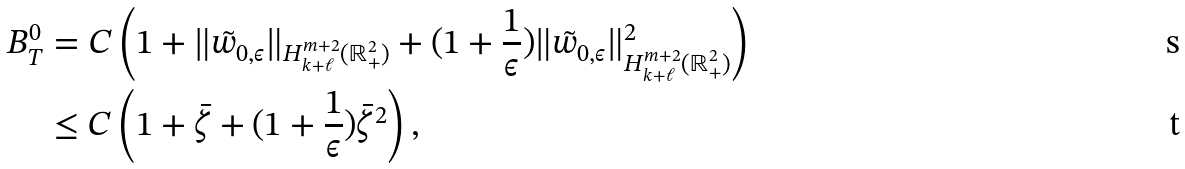Convert formula to latex. <formula><loc_0><loc_0><loc_500><loc_500>B ^ { 0 } _ { T } & = C \left ( 1 + \| \tilde { w } _ { 0 , \epsilon } \| _ { H ^ { m + 2 } _ { k + \ell } ( \mathbb { R } ^ { 2 } _ { + } ) } + ( 1 + \frac { 1 } { \epsilon } ) \| \tilde { w } _ { 0 , \epsilon } \| ^ { 2 } _ { H ^ { m + 2 } _ { k + \ell } ( \mathbb { R } ^ { 2 } _ { + } ) } \right ) \\ & \leq C \left ( 1 + \bar { \zeta } + ( 1 + \frac { 1 } { \epsilon } ) \bar { \zeta } ^ { 2 } \right ) ,</formula> 